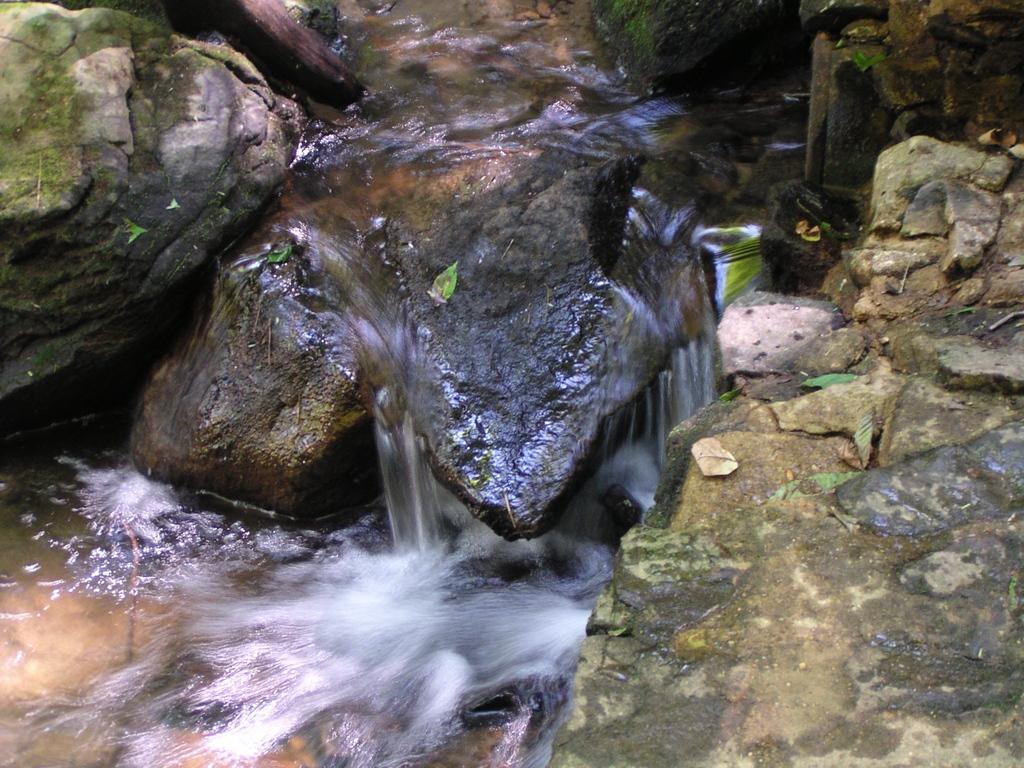Describe this image in one or two sentences. In this picture I can see water, there are rocks and leaves. 